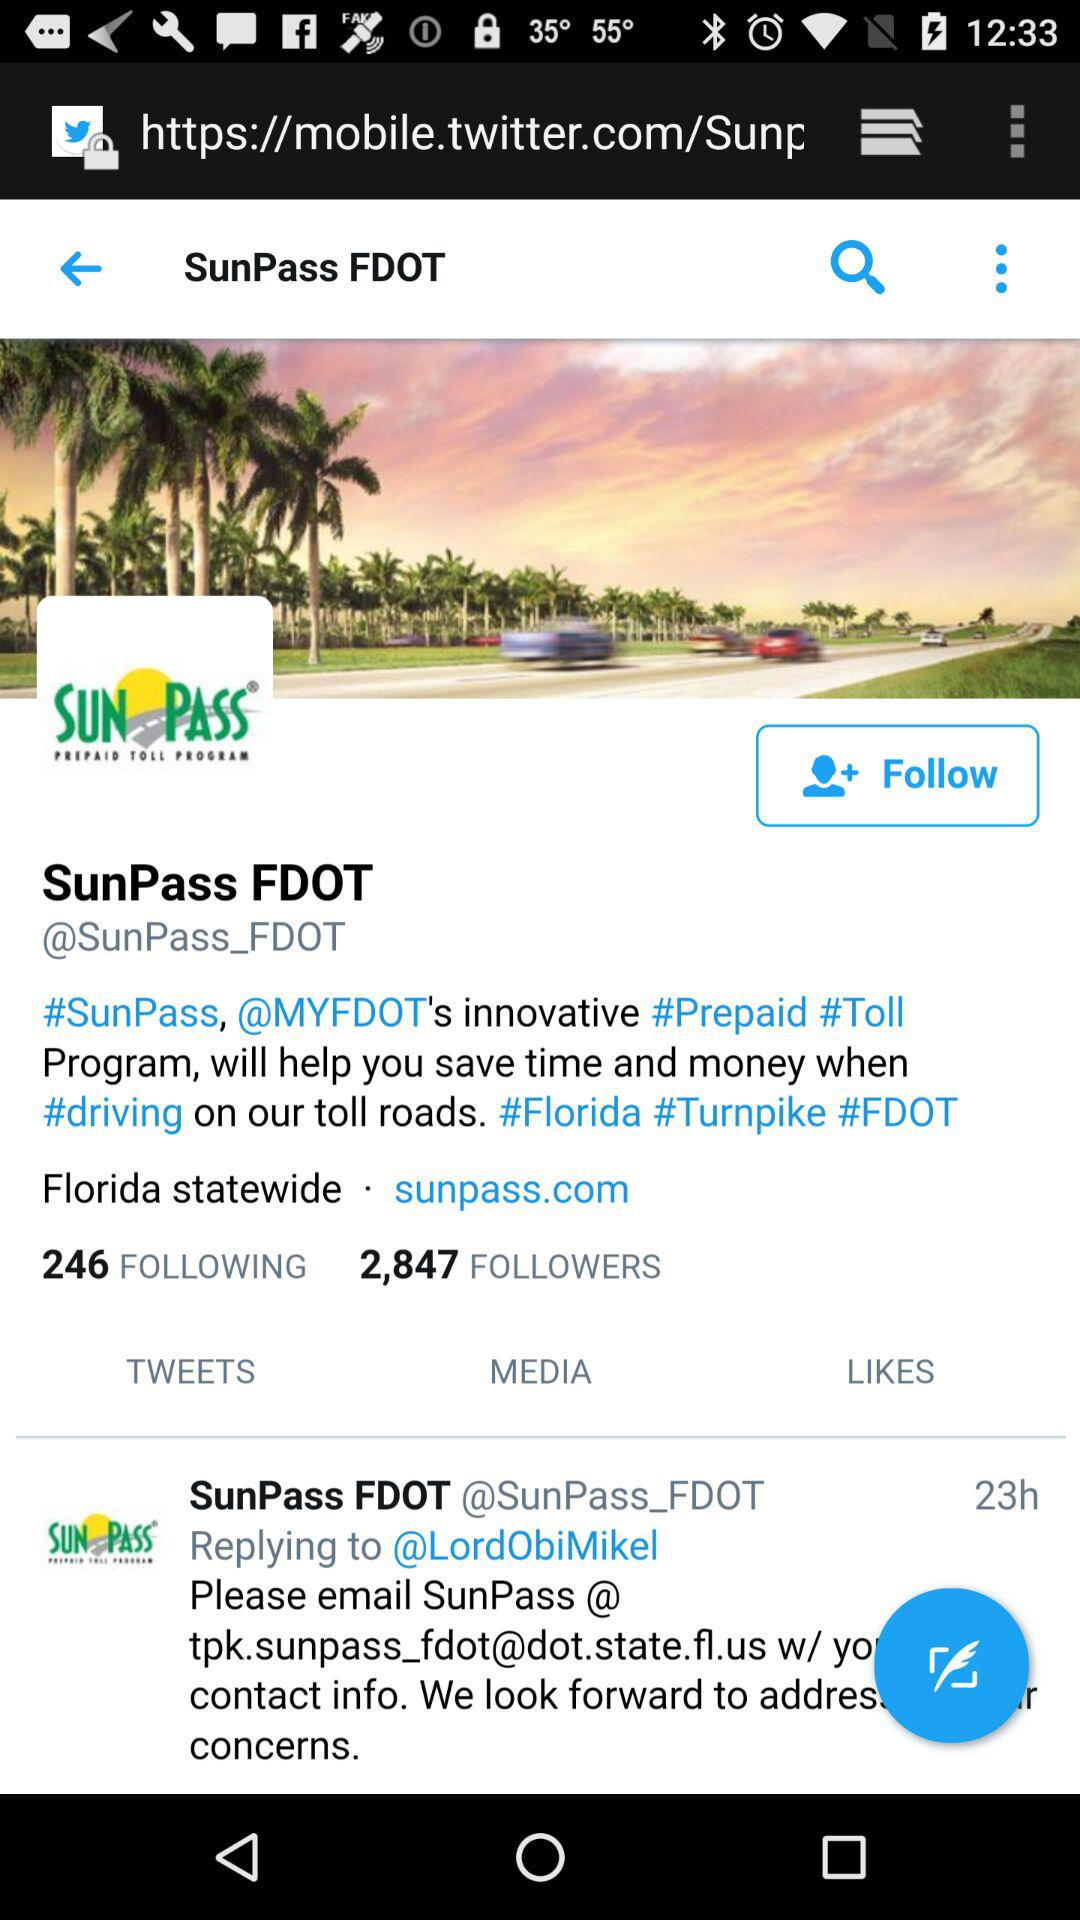How many followers are there for "SunPass_FDOT"? There are 2,847 followers for "SunPass_FDOT". 